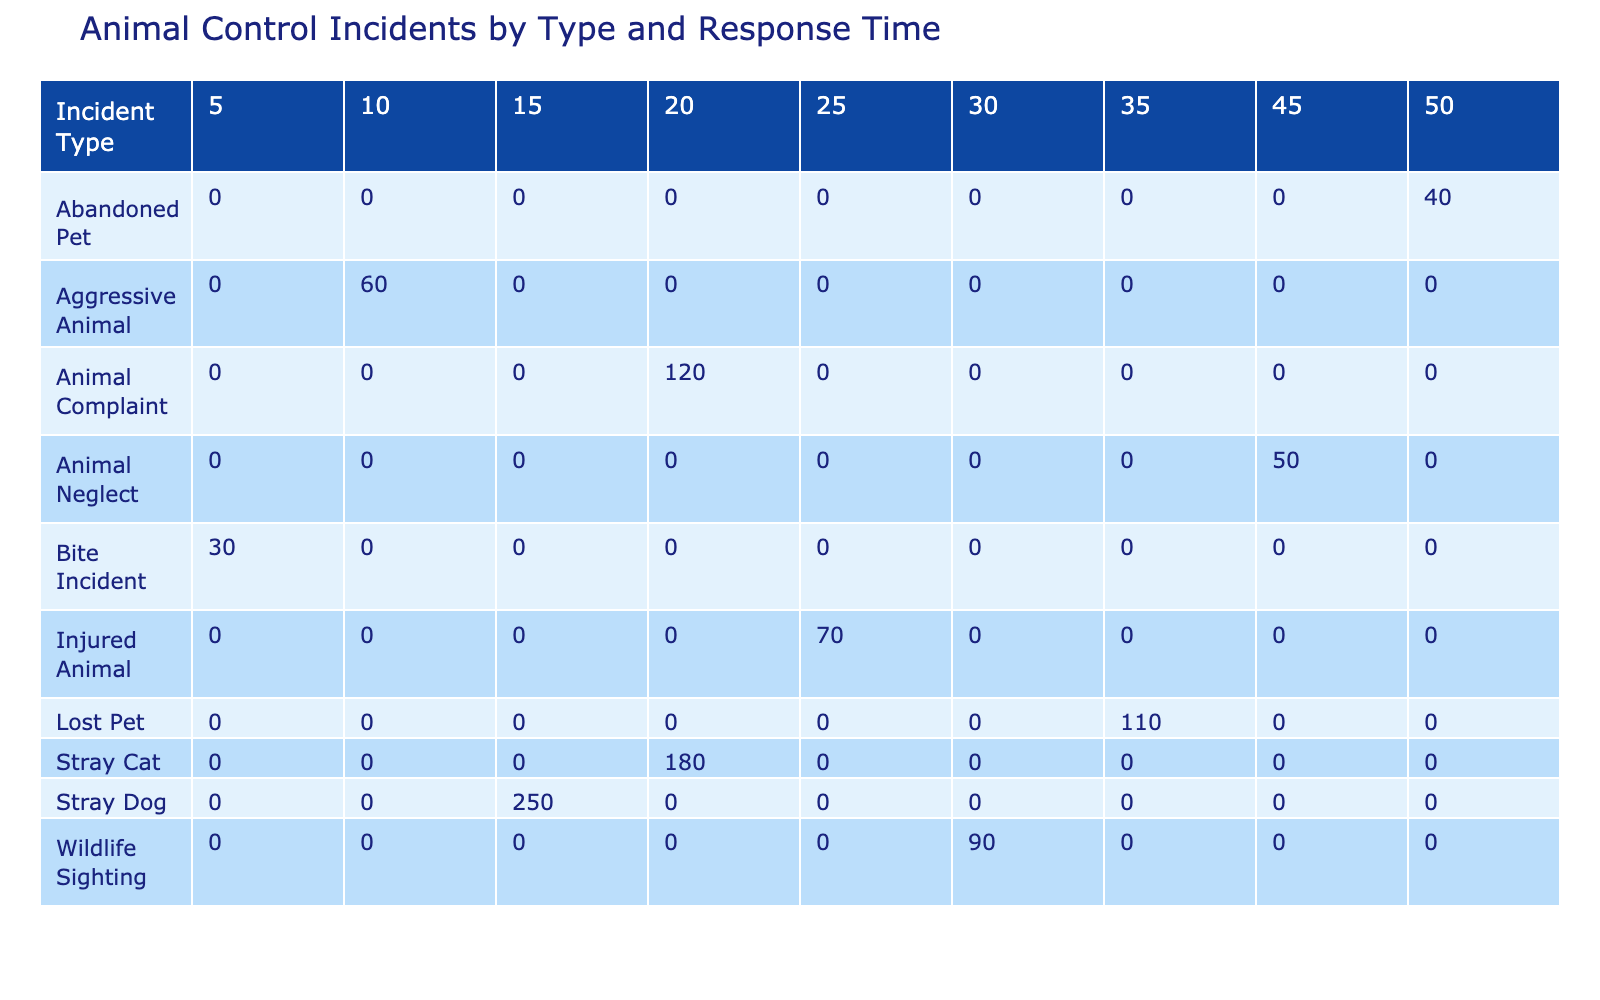What is the total number of incidents for stray dogs? To find the total number of incidents for stray dogs, I refer to the table and look for the row corresponding to "Stray Dog". The Incident Count for Stray Dogs is 250.
Answer: 250 Which incident type has the highest response time? In the table, I check the response times for each incident type and find that "Abandoned Pet" has the highest response time of 50 minutes.
Answer: Abandoned Pet Are there more incidents of animal complaints than aggressive animals? I compare the Incident Count for "Animal Complaint", which is 120, with "Aggressive Animal", which has 60 incidents. Since 120 is greater than 60, the answer is yes.
Answer: Yes What is the average response time for wildlife sightings and injured animals? I first find the response times for these two incident types: Wildlife Sighting is 30 minutes and Injured Animal is 25 minutes. The average response time is calculated as (30 + 25) / 2 = 27.5 minutes.
Answer: 27.5 How many total incidents were recorded for all types requiring a response time of over 30 minutes? I analyze the table for all incident types with response times greater than 30 minutes. These are "Lost Pet" (110 incidents), "Abandoned Pet" (40 incidents), summing them gives 110 + 40 = 150 incidents.
Answer: 150 Is the number of bite incidents greater than the sum of stray cat and stray dog incidents? First, I note that Bite Incidents total 30. Then, I sum the Stray Dog (250) and Stray Cat (180) incidents, which equals 430. Since 30 is less than 430, the answer is no.
Answer: No What is the difference between the number of injuries and that of neglect incidents? I look at the Incident Counts: Injured Animal has 70 incidents, and Animal Neglect has 50 incidents. The difference is calculated as 70 - 50 = 20 incidents.
Answer: 20 Which types of incidents have a response time of less than 20 minutes? I examine the table for incident types with response times under 20 minutes. These are "Bite Incident" (5 minutes), "Aggressive Animal" (10 minutes), and "Stray Dog" (15 minutes). The incidents are Bite Incident, Aggressive Animal, and Stray Dog.
Answer: Bite Incident, Aggressive Animal, Stray Dog 